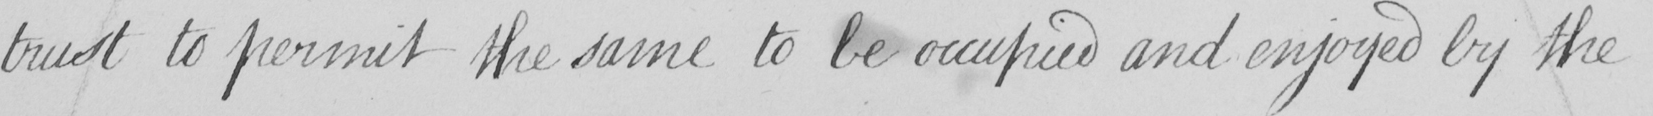Can you tell me what this handwritten text says? trust to permit the same to be occupied and enjoyed by the 